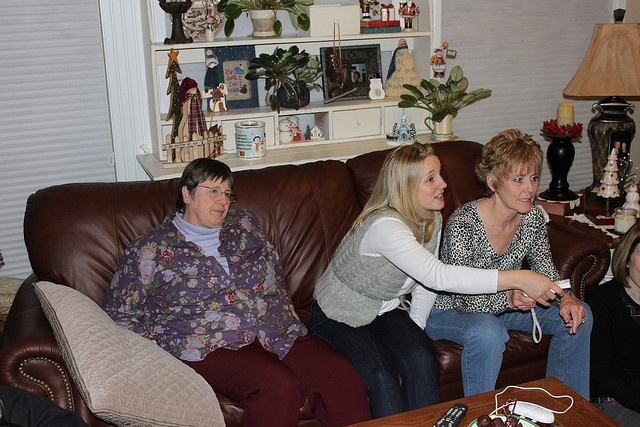Describe the objects in this image and their specific colors. I can see couch in darkgray, black, maroon, and gray tones, people in darkgray, black, gray, and purple tones, people in darkgray, black, lightgray, and gray tones, people in darkgray, gray, blue, and black tones, and people in darkgray, black, and gray tones in this image. 